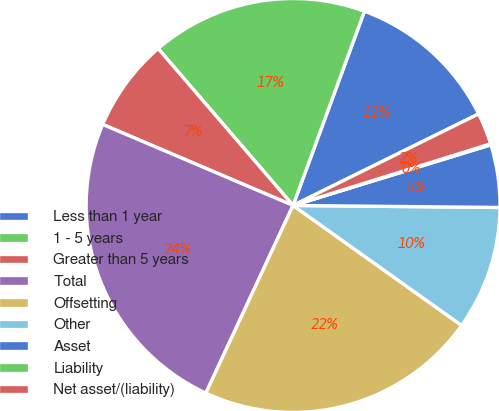Convert chart. <chart><loc_0><loc_0><loc_500><loc_500><pie_chart><fcel>Less than 1 year<fcel>1 - 5 years<fcel>Greater than 5 years<fcel>Total<fcel>Offsetting<fcel>Other<fcel>Asset<fcel>Liability<fcel>Net asset/(liability)<nl><fcel>12.1%<fcel>16.91%<fcel>7.29%<fcel>24.48%<fcel>22.08%<fcel>9.69%<fcel>4.89%<fcel>0.08%<fcel>2.48%<nl></chart> 